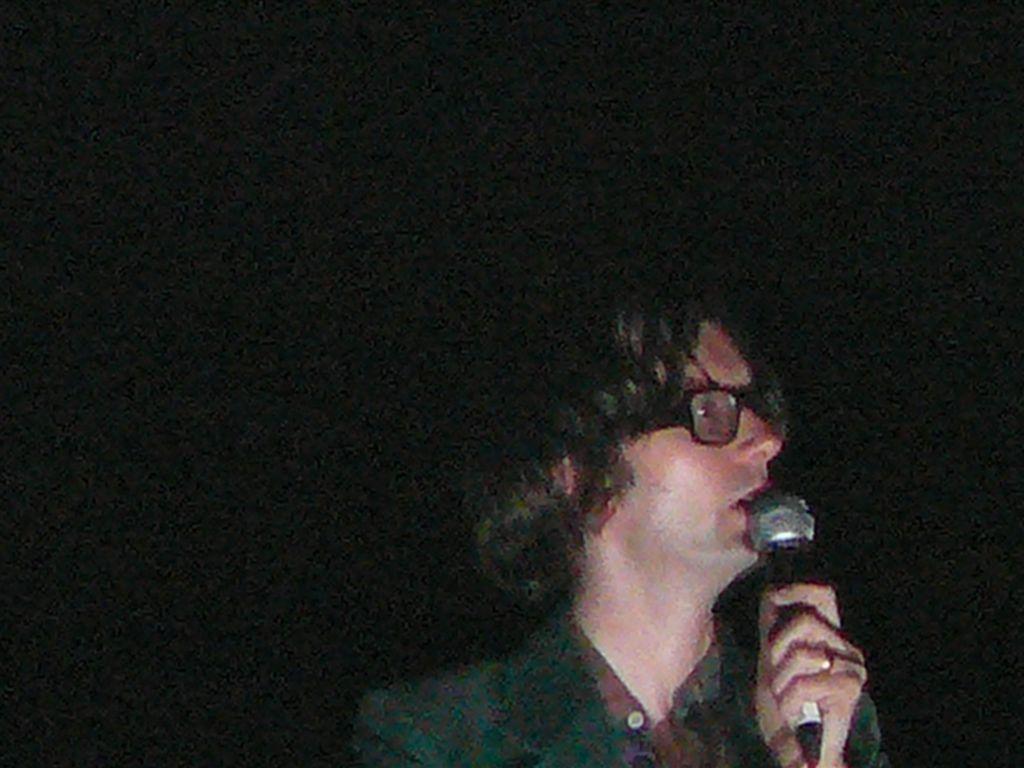Can you describe this image briefly? Here a person is speaking in the microphone, this person wore shirt, coat, spectacles. 